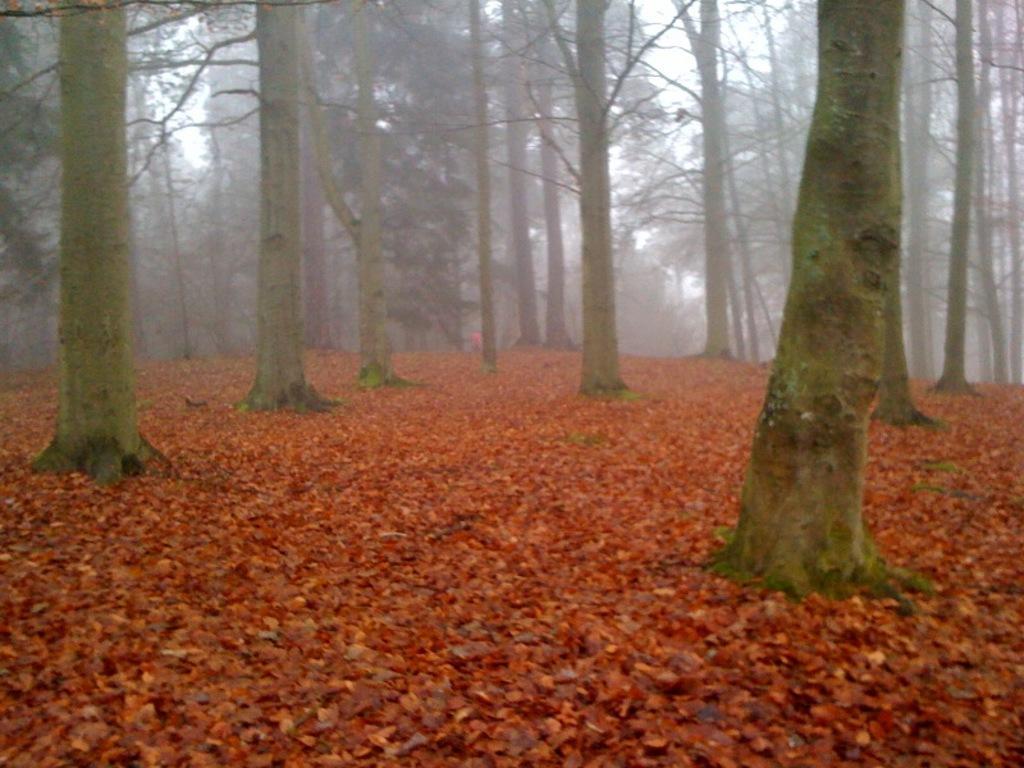Describe this image in one or two sentences. In this image there is a land that is covered with leaves, in the background there are trees. 